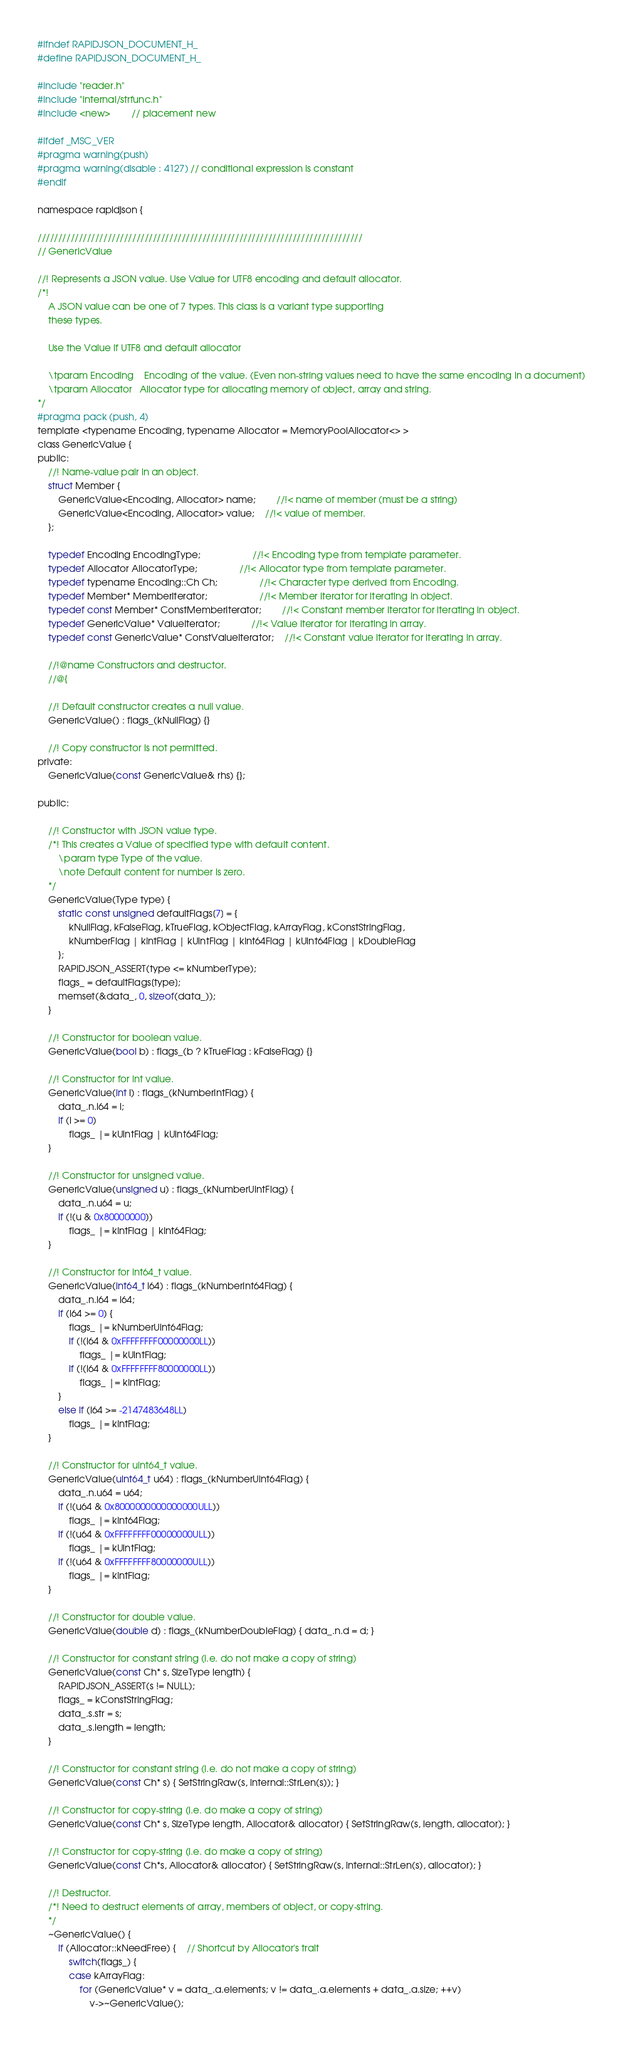Convert code to text. <code><loc_0><loc_0><loc_500><loc_500><_C_>#ifndef RAPIDJSON_DOCUMENT_H_
#define RAPIDJSON_DOCUMENT_H_

#include "reader.h"
#include "internal/strfunc.h"
#include <new>		// placement new

#ifdef _MSC_VER
#pragma warning(push)
#pragma warning(disable : 4127) // conditional expression is constant
#endif

namespace rapidjson {

///////////////////////////////////////////////////////////////////////////////
// GenericValue

//! Represents a JSON value. Use Value for UTF8 encoding and default allocator.
/*!
	A JSON value can be one of 7 types. This class is a variant type supporting
	these types.

	Use the Value if UTF8 and default allocator

	\tparam Encoding	Encoding of the value. (Even non-string values need to have the same encoding in a document)
	\tparam Allocator	Allocator type for allocating memory of object, array and string.
*/
#pragma pack (push, 4)
template <typename Encoding, typename Allocator = MemoryPoolAllocator<> > 
class GenericValue {
public:
	//! Name-value pair in an object.
	struct Member { 
		GenericValue<Encoding, Allocator> name;		//!< name of member (must be a string)
		GenericValue<Encoding, Allocator> value;	//!< value of member.
	};

	typedef Encoding EncodingType;					//!< Encoding type from template parameter.
	typedef Allocator AllocatorType;				//!< Allocator type from template parameter.
	typedef typename Encoding::Ch Ch;				//!< Character type derived from Encoding.
	typedef Member* MemberIterator;					//!< Member iterator for iterating in object.
	typedef const Member* ConstMemberIterator;		//!< Constant member iterator for iterating in object.
	typedef GenericValue* ValueIterator;			//!< Value iterator for iterating in array.
	typedef const GenericValue* ConstValueIterator;	//!< Constant value iterator for iterating in array.

	//!@name Constructors and destructor.
	//@{

	//! Default constructor creates a null value.
	GenericValue() : flags_(kNullFlag) {}

	//! Copy constructor is not permitted.
private:
	GenericValue(const GenericValue& rhs) {};

public:

	//! Constructor with JSON value type.
	/*! This creates a Value of specified type with default content.
		\param type	Type of the value.
		\note Default content for number is zero.
	*/
	GenericValue(Type type) {
		static const unsigned defaultFlags[7] = {
			kNullFlag, kFalseFlag, kTrueFlag, kObjectFlag, kArrayFlag, kConstStringFlag,
			kNumberFlag | kIntFlag | kUintFlag | kInt64Flag | kUint64Flag | kDoubleFlag
		};
		RAPIDJSON_ASSERT(type <= kNumberType);
		flags_ = defaultFlags[type];
		memset(&data_, 0, sizeof(data_));
	}

	//! Constructor for boolean value.
	GenericValue(bool b) : flags_(b ? kTrueFlag : kFalseFlag) {}

	//! Constructor for int value.
	GenericValue(int i) : flags_(kNumberIntFlag) { 
		data_.n.i64 = i;
		if (i >= 0)
			flags_ |= kUintFlag | kUint64Flag;
	}

	//! Constructor for unsigned value.
	GenericValue(unsigned u) : flags_(kNumberUintFlag) {
		data_.n.u64 = u; 
		if (!(u & 0x80000000))
			flags_ |= kIntFlag | kInt64Flag;
	}

	//! Constructor for int64_t value.
	GenericValue(int64_t i64) : flags_(kNumberInt64Flag) {
		data_.n.i64 = i64;
		if (i64 >= 0) {
			flags_ |= kNumberUint64Flag;
			if (!(i64 & 0xFFFFFFFF00000000LL))
				flags_ |= kUintFlag;
			if (!(i64 & 0xFFFFFFFF80000000LL))
				flags_ |= kIntFlag;
		}
		else if (i64 >= -2147483648LL)
			flags_ |= kIntFlag;
	}

	//! Constructor for uint64_t value.
	GenericValue(uint64_t u64) : flags_(kNumberUint64Flag) {
		data_.n.u64 = u64;
		if (!(u64 & 0x8000000000000000ULL))
			flags_ |= kInt64Flag;
		if (!(u64 & 0xFFFFFFFF00000000ULL))
			flags_ |= kUintFlag;
		if (!(u64 & 0xFFFFFFFF80000000ULL))
			flags_ |= kIntFlag;
	}

	//! Constructor for double value.
	GenericValue(double d) : flags_(kNumberDoubleFlag) { data_.n.d = d; }

	//! Constructor for constant string (i.e. do not make a copy of string)
	GenericValue(const Ch* s, SizeType length) { 
		RAPIDJSON_ASSERT(s != NULL);
		flags_ = kConstStringFlag;
		data_.s.str = s;
		data_.s.length = length;
	}

	//! Constructor for constant string (i.e. do not make a copy of string)
	GenericValue(const Ch* s) { SetStringRaw(s, internal::StrLen(s)); }

	//! Constructor for copy-string (i.e. do make a copy of string)
	GenericValue(const Ch* s, SizeType length, Allocator& allocator) { SetStringRaw(s, length, allocator); }

	//! Constructor for copy-string (i.e. do make a copy of string)
	GenericValue(const Ch*s, Allocator& allocator) { SetStringRaw(s, internal::StrLen(s), allocator); }

	//! Destructor.
	/*! Need to destruct elements of array, members of object, or copy-string.
	*/
	~GenericValue() {
		if (Allocator::kNeedFree) {	// Shortcut by Allocator's trait
			switch(flags_) {
			case kArrayFlag:
				for (GenericValue* v = data_.a.elements; v != data_.a.elements + data_.a.size; ++v)
					v->~GenericValue();</code> 